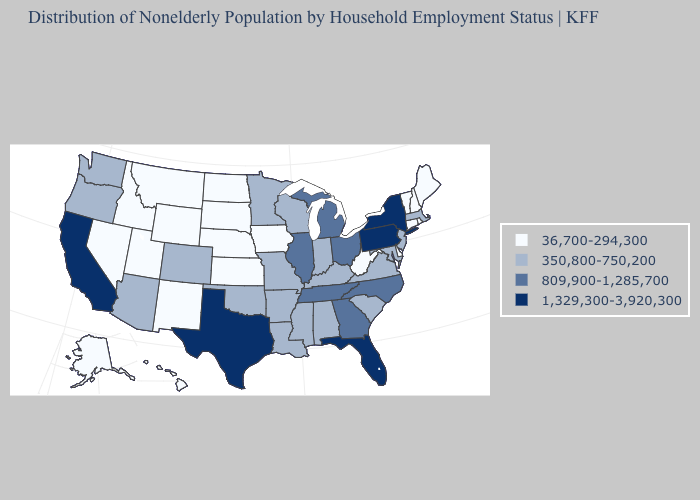What is the value of Kansas?
Write a very short answer. 36,700-294,300. Among the states that border North Carolina , which have the lowest value?
Write a very short answer. South Carolina, Virginia. What is the highest value in the USA?
Give a very brief answer. 1,329,300-3,920,300. Does Texas have the highest value in the USA?
Concise answer only. Yes. Does Kansas have the same value as Maine?
Write a very short answer. Yes. Among the states that border Oregon , which have the highest value?
Be succinct. California. Among the states that border Connecticut , does Massachusetts have the lowest value?
Be succinct. No. Name the states that have a value in the range 809,900-1,285,700?
Write a very short answer. Georgia, Illinois, Michigan, North Carolina, Ohio, Tennessee. What is the highest value in states that border Arizona?
Give a very brief answer. 1,329,300-3,920,300. Does Kansas have a higher value than Delaware?
Answer briefly. No. Name the states that have a value in the range 1,329,300-3,920,300?
Quick response, please. California, Florida, New York, Pennsylvania, Texas. Name the states that have a value in the range 809,900-1,285,700?
Answer briefly. Georgia, Illinois, Michigan, North Carolina, Ohio, Tennessee. Does Indiana have the highest value in the MidWest?
Quick response, please. No. What is the lowest value in the West?
Be succinct. 36,700-294,300. 